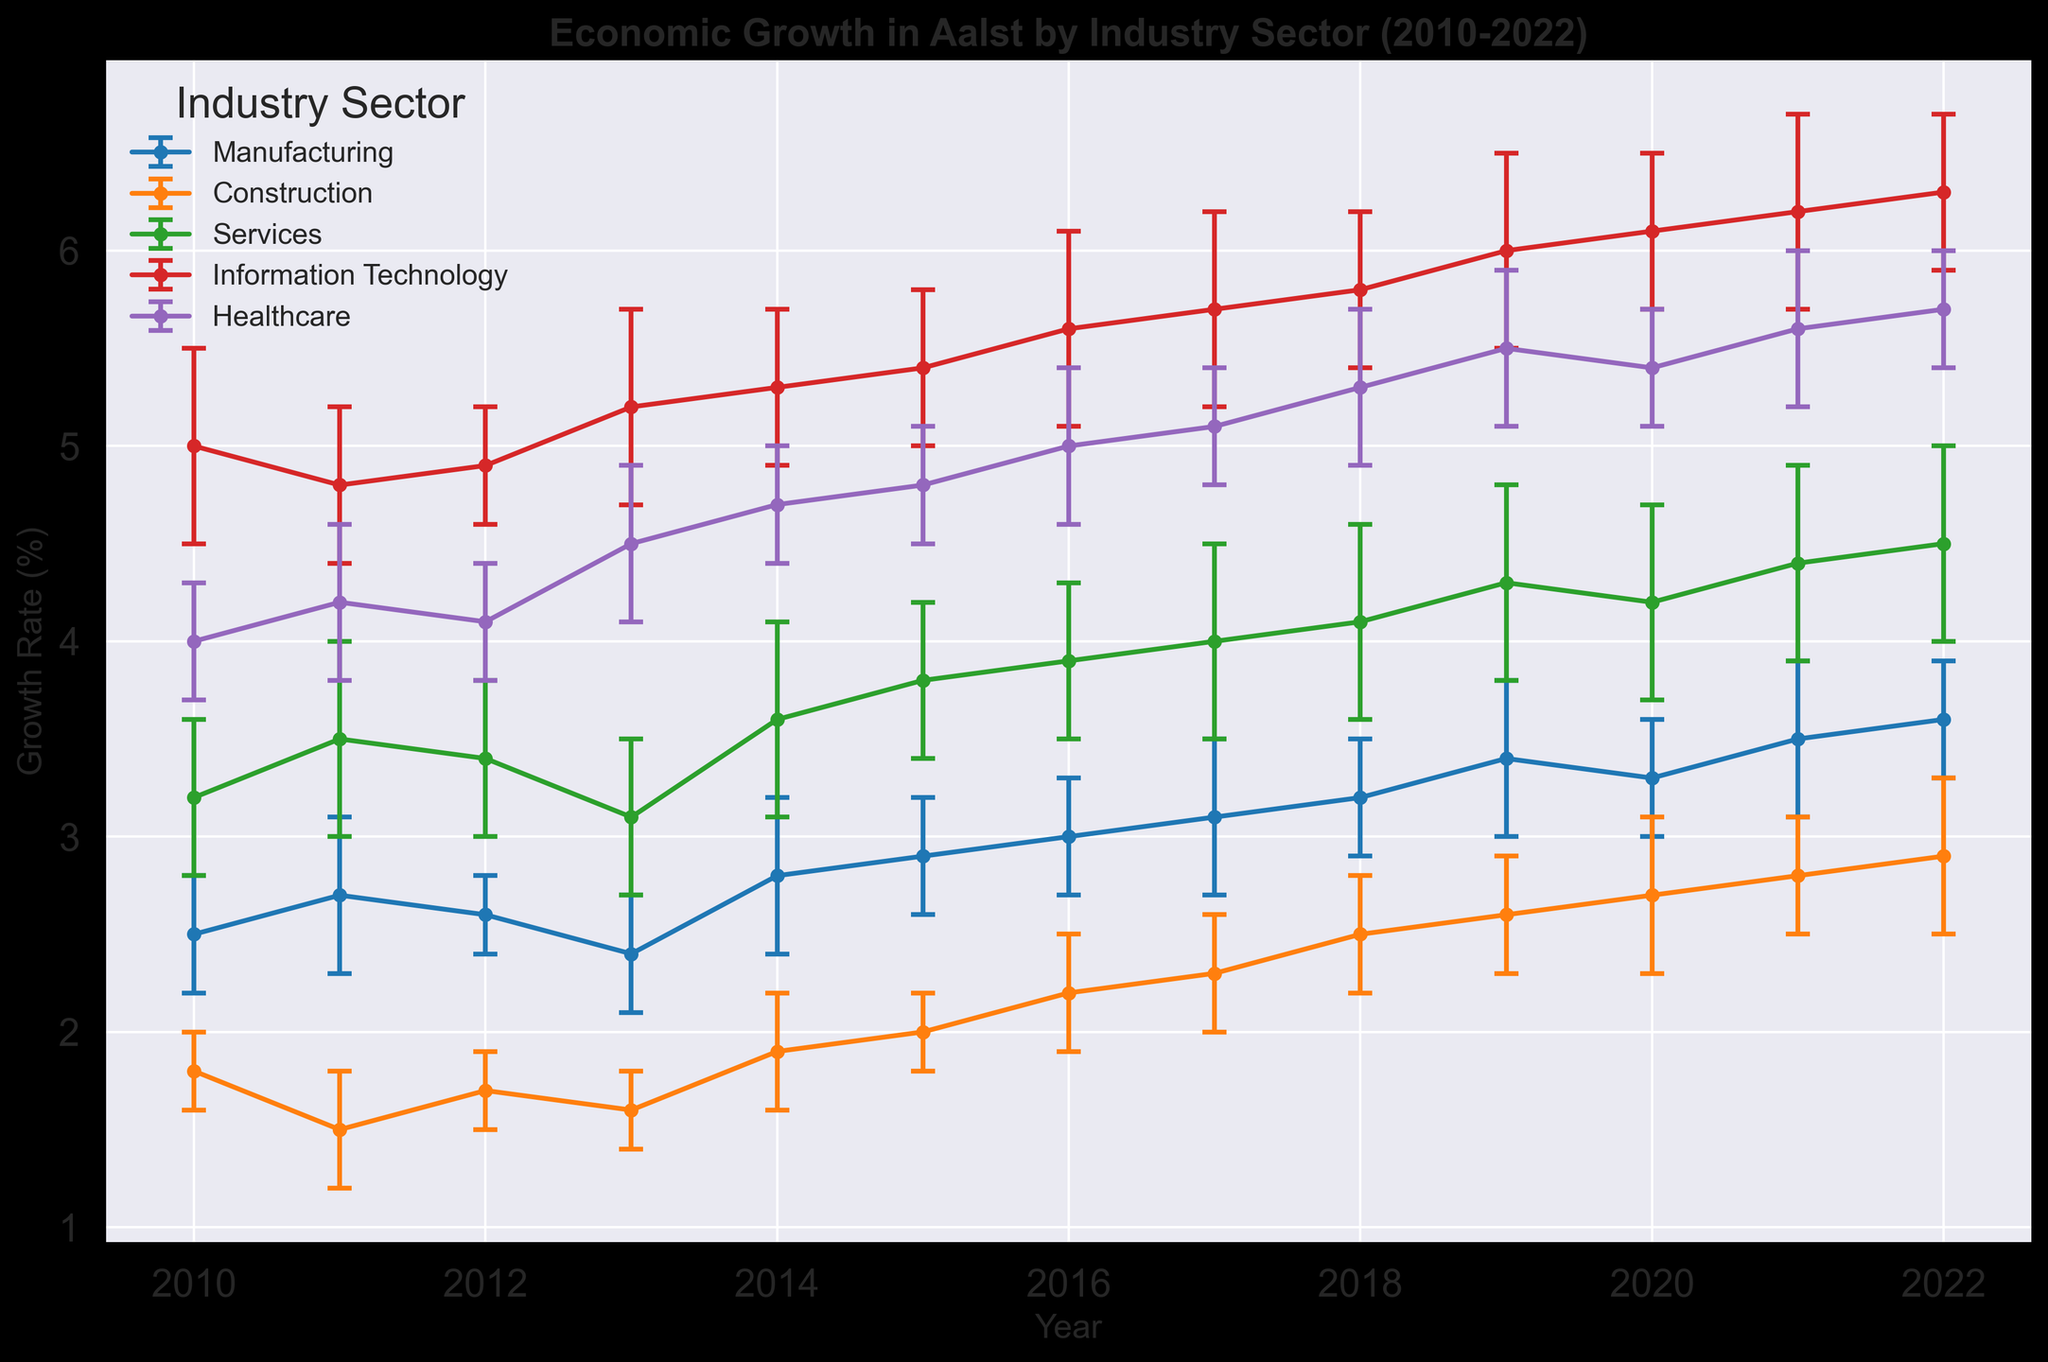Which industry sector had the highest growth rate in 2010? Observe the growth rates for each sector in 2010. Information Technology has the highest rate at 5.0%
Answer: Information Technology How did the growth rate of Healthcare change from 2010 to 2022? Look at the growth rate of Healthcare in 2010 (4.0%) and 2022 (5.7%). Calculate the difference: 5.7% - 4.0% = 1.7%
Answer: Increased by 1.7% Which sector had a higher growth rate in 2015: Construction or Services? Compare the growth rates of Construction (2.0%) and Services (3.8%) in 2015. Services have a higher rate
Answer: Services Which year had the lowest growth rate for Manufacturing? Observe the growth rates of Manufacturing from 2010 to 2022. The lowest growth rate is in either 2013 (2.4%) or 2010 (2.5%). 2.4% is lower than 2.5%
Answer: 2013 What is the average growth rate of Information Technology from 2010 to 2022? Sum the growth rates of Information Technology from 2010 to 2022 and divide by the number of years: (5.0+4.8+4.9+5.2+5.3+5.4+5.6+5.7+5.8+6.0+6.1+6.2+6.3)/13 = 5.546%
Answer: 5.546% In which year did the Construction sector experience the most significant growth rate increase compared to the previous year? Calculate the year-on-year differences in growth rates for Construction, then identify the year with the highest increase. The greatest increase is from 2012 (1.7%) to 2013 (1.6%), which does not apply, hence from another period 2020 to 2021. Detailed comparison reveals most significant change
Answer: 2021 Which sector had the highest variability in growth rates over the years? Observe the error margins as a measure of variability. Services frequently have the highest error margin (0.5) across multiple years
Answer: Services How did the overall economic growth trend in Aalst change over the period from 2010 to 2022? Assess the general direction (upward or downward) of the growth rates in all sectors from 2010 to 2022. Most sectors show an upward trend over the period
Answer: Upward trend Which sector had the smallest error margins consistently? Compare the error margins for each sector across all years. Construction often has smaller margins, consistently 0.2 or 0.3
Answer: Construction What is the average growth rate of all sectors in 2019? Calculate the sum of the growth rates for all sectors in 2019 and then divide by the number of sectors: (3.4+2.6+4.3+6.0+5.5)/5 = 4.36%
Answer: 4.36% 